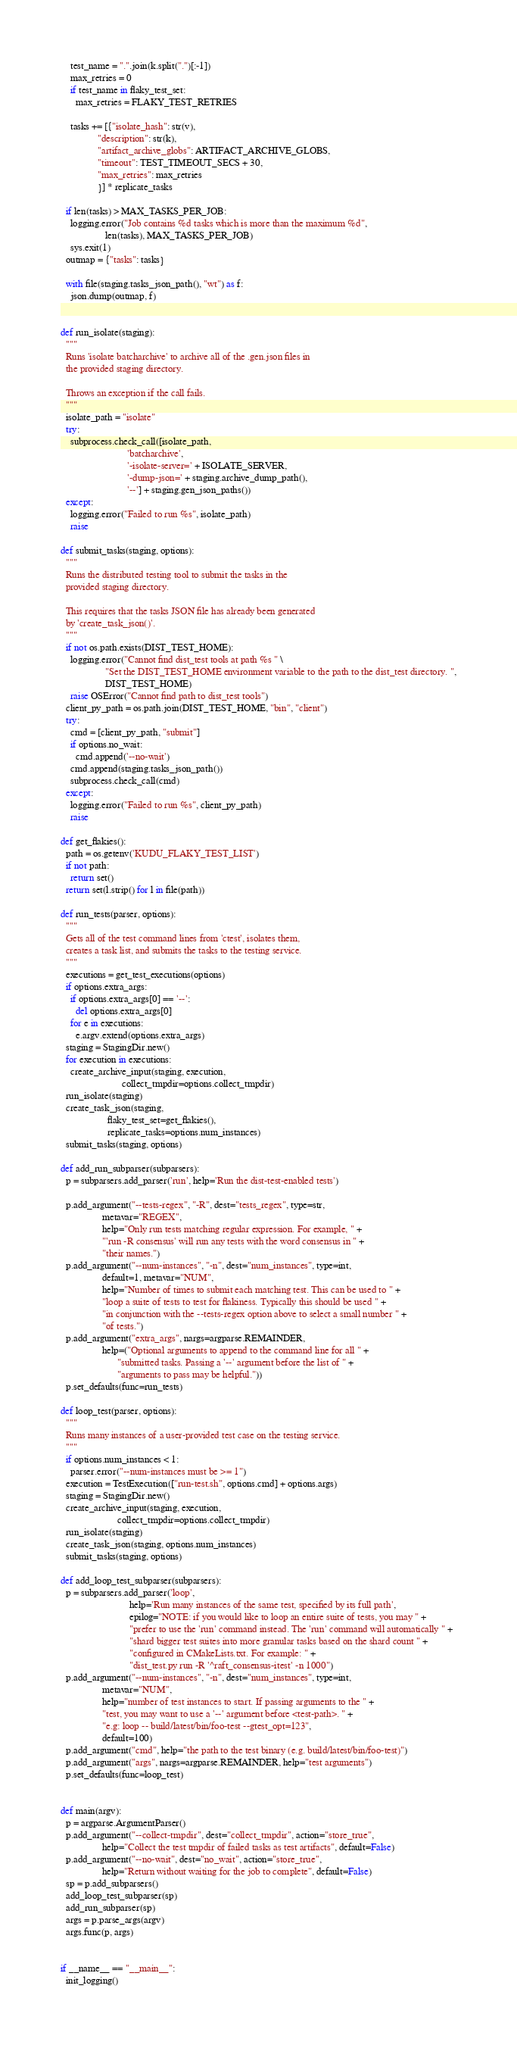Convert code to text. <code><loc_0><loc_0><loc_500><loc_500><_Python_>    test_name = ".".join(k.split(".")[:-1])
    max_retries = 0
    if test_name in flaky_test_set:
      max_retries = FLAKY_TEST_RETRIES

    tasks += [{"isolate_hash": str(v),
               "description": str(k),
               "artifact_archive_globs": ARTIFACT_ARCHIVE_GLOBS,
               "timeout": TEST_TIMEOUT_SECS + 30,
               "max_retries": max_retries
               }] * replicate_tasks

  if len(tasks) > MAX_TASKS_PER_JOB:
    logging.error("Job contains %d tasks which is more than the maximum %d",
                  len(tasks), MAX_TASKS_PER_JOB)
    sys.exit(1)
  outmap = {"tasks": tasks}

  with file(staging.tasks_json_path(), "wt") as f:
    json.dump(outmap, f)


def run_isolate(staging):
  """
  Runs 'isolate batcharchive' to archive all of the .gen.json files in
  the provided staging directory.

  Throws an exception if the call fails.
  """
  isolate_path = "isolate"
  try:
    subprocess.check_call([isolate_path,
                           'batcharchive',
                           '-isolate-server=' + ISOLATE_SERVER,
                           '-dump-json=' + staging.archive_dump_path(),
                           '--'] + staging.gen_json_paths())
  except:
    logging.error("Failed to run %s", isolate_path)
    raise

def submit_tasks(staging, options):
  """
  Runs the distributed testing tool to submit the tasks in the
  provided staging directory.

  This requires that the tasks JSON file has already been generated
  by 'create_task_json()'.
  """
  if not os.path.exists(DIST_TEST_HOME):
    logging.error("Cannot find dist_test tools at path %s " \
                  "Set the DIST_TEST_HOME environment variable to the path to the dist_test directory. ",
                  DIST_TEST_HOME)
    raise OSError("Cannot find path to dist_test tools")
  client_py_path = os.path.join(DIST_TEST_HOME, "bin", "client")
  try:
    cmd = [client_py_path, "submit"]
    if options.no_wait:
      cmd.append('--no-wait')
    cmd.append(staging.tasks_json_path())
    subprocess.check_call(cmd)
  except:
    logging.error("Failed to run %s", client_py_path)
    raise

def get_flakies():
  path = os.getenv('KUDU_FLAKY_TEST_LIST')
  if not path:
    return set()
  return set(l.strip() for l in file(path))

def run_tests(parser, options):
  """
  Gets all of the test command lines from 'ctest', isolates them,
  creates a task list, and submits the tasks to the testing service.
  """
  executions = get_test_executions(options)
  if options.extra_args:
    if options.extra_args[0] == '--':
      del options.extra_args[0]
    for e in executions:
      e.argv.extend(options.extra_args)
  staging = StagingDir.new()
  for execution in executions:
    create_archive_input(staging, execution,
                         collect_tmpdir=options.collect_tmpdir)
  run_isolate(staging)
  create_task_json(staging,
                   flaky_test_set=get_flakies(),
                   replicate_tasks=options.num_instances)
  submit_tasks(staging, options)

def add_run_subparser(subparsers):
  p = subparsers.add_parser('run', help='Run the dist-test-enabled tests')

  p.add_argument("--tests-regex", "-R", dest="tests_regex", type=str,
                 metavar="REGEX",
                 help="Only run tests matching regular expression. For example, " +
                 "'run -R consensus' will run any tests with the word consensus in " +
                 "their names.")
  p.add_argument("--num-instances", "-n", dest="num_instances", type=int,
                 default=1, metavar="NUM",
                 help="Number of times to submit each matching test. This can be used to " +
                 "loop a suite of tests to test for flakiness. Typically this should be used " +
                 "in conjunction with the --tests-regex option above to select a small number " +
                 "of tests.")
  p.add_argument("extra_args", nargs=argparse.REMAINDER,
                 help=("Optional arguments to append to the command line for all " +
                       "submitted tasks. Passing a '--' argument before the list of " +
                       "arguments to pass may be helpful."))
  p.set_defaults(func=run_tests)

def loop_test(parser, options):
  """
  Runs many instances of a user-provided test case on the testing service.
  """
  if options.num_instances < 1:
    parser.error("--num-instances must be >= 1")
  execution = TestExecution(["run-test.sh", options.cmd] + options.args)
  staging = StagingDir.new()
  create_archive_input(staging, execution,
                       collect_tmpdir=options.collect_tmpdir)
  run_isolate(staging)
  create_task_json(staging, options.num_instances)
  submit_tasks(staging, options)

def add_loop_test_subparser(subparsers):
  p = subparsers.add_parser('loop',
                            help='Run many instances of the same test, specified by its full path',
                            epilog="NOTE: if you would like to loop an entire suite of tests, you may " +
                            "prefer to use the 'run' command instead. The 'run' command will automatically " +
                            "shard bigger test suites into more granular tasks based on the shard count " +
                            "configured in CMakeLists.txt. For example: " +
                            "dist_test.py run -R '^raft_consensus-itest' -n 1000")
  p.add_argument("--num-instances", "-n", dest="num_instances", type=int,
                 metavar="NUM",
                 help="number of test instances to start. If passing arguments to the " +
                 "test, you may want to use a '--' argument before <test-path>. " +
                 "e.g: loop -- build/latest/bin/foo-test --gtest_opt=123",
                 default=100)
  p.add_argument("cmd", help="the path to the test binary (e.g. build/latest/bin/foo-test)")
  p.add_argument("args", nargs=argparse.REMAINDER, help="test arguments")
  p.set_defaults(func=loop_test)


def main(argv):
  p = argparse.ArgumentParser()
  p.add_argument("--collect-tmpdir", dest="collect_tmpdir", action="store_true",
                 help="Collect the test tmpdir of failed tasks as test artifacts", default=False)
  p.add_argument("--no-wait", dest="no_wait", action="store_true",
                 help="Return without waiting for the job to complete", default=False)
  sp = p.add_subparsers()
  add_loop_test_subparser(sp)
  add_run_subparser(sp)
  args = p.parse_args(argv)
  args.func(p, args)


if __name__ == "__main__":
  init_logging()</code> 